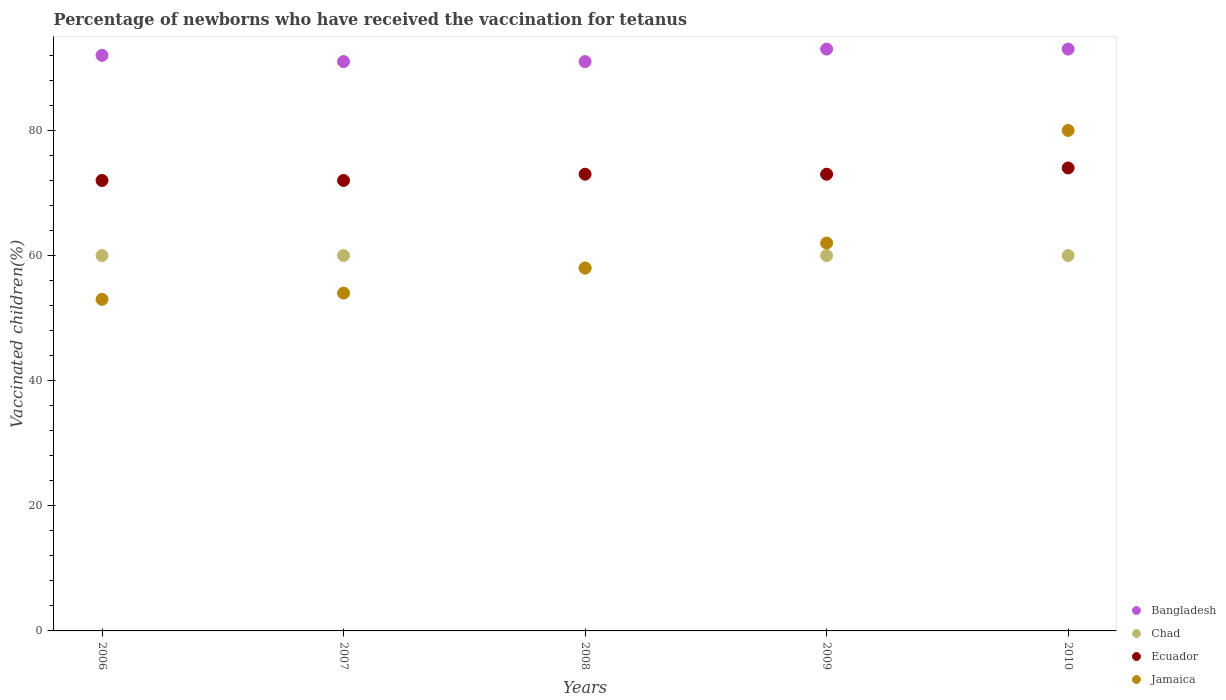Is the number of dotlines equal to the number of legend labels?
Make the answer very short. Yes. What is the percentage of vaccinated children in Bangladesh in 2010?
Give a very brief answer. 93. Across all years, what is the maximum percentage of vaccinated children in Bangladesh?
Offer a very short reply. 93. Across all years, what is the minimum percentage of vaccinated children in Chad?
Provide a short and direct response. 58. In which year was the percentage of vaccinated children in Bangladesh maximum?
Provide a short and direct response. 2009. What is the total percentage of vaccinated children in Jamaica in the graph?
Make the answer very short. 307. What is the difference between the percentage of vaccinated children in Jamaica in 2009 and the percentage of vaccinated children in Bangladesh in 2007?
Give a very brief answer. -29. What is the average percentage of vaccinated children in Jamaica per year?
Provide a succinct answer. 61.4. What is the ratio of the percentage of vaccinated children in Chad in 2007 to that in 2009?
Offer a very short reply. 1. Is the percentage of vaccinated children in Chad in 2007 less than that in 2008?
Provide a succinct answer. No. Is the difference between the percentage of vaccinated children in Chad in 2007 and 2010 greater than the difference between the percentage of vaccinated children in Ecuador in 2007 and 2010?
Provide a succinct answer. Yes. What is the difference between the highest and the lowest percentage of vaccinated children in Ecuador?
Provide a succinct answer. 2. Is the sum of the percentage of vaccinated children in Bangladesh in 2006 and 2009 greater than the maximum percentage of vaccinated children in Chad across all years?
Provide a short and direct response. Yes. Is it the case that in every year, the sum of the percentage of vaccinated children in Chad and percentage of vaccinated children in Bangladesh  is greater than the sum of percentage of vaccinated children in Ecuador and percentage of vaccinated children in Jamaica?
Offer a terse response. Yes. How many dotlines are there?
Make the answer very short. 4. How many years are there in the graph?
Offer a terse response. 5. What is the difference between two consecutive major ticks on the Y-axis?
Offer a very short reply. 20. Are the values on the major ticks of Y-axis written in scientific E-notation?
Provide a short and direct response. No. Does the graph contain any zero values?
Make the answer very short. No. How many legend labels are there?
Make the answer very short. 4. How are the legend labels stacked?
Provide a succinct answer. Vertical. What is the title of the graph?
Ensure brevity in your answer.  Percentage of newborns who have received the vaccination for tetanus. What is the label or title of the Y-axis?
Your answer should be compact. Vaccinated children(%). What is the Vaccinated children(%) of Bangladesh in 2006?
Your response must be concise. 92. What is the Vaccinated children(%) of Chad in 2006?
Offer a terse response. 60. What is the Vaccinated children(%) in Ecuador in 2006?
Your answer should be compact. 72. What is the Vaccinated children(%) of Bangladesh in 2007?
Offer a terse response. 91. What is the Vaccinated children(%) in Chad in 2007?
Your response must be concise. 60. What is the Vaccinated children(%) in Bangladesh in 2008?
Your answer should be compact. 91. What is the Vaccinated children(%) of Jamaica in 2008?
Offer a terse response. 58. What is the Vaccinated children(%) in Bangladesh in 2009?
Make the answer very short. 93. What is the Vaccinated children(%) in Ecuador in 2009?
Your answer should be compact. 73. What is the Vaccinated children(%) in Bangladesh in 2010?
Your answer should be very brief. 93. What is the Vaccinated children(%) of Jamaica in 2010?
Provide a short and direct response. 80. Across all years, what is the maximum Vaccinated children(%) of Bangladesh?
Make the answer very short. 93. Across all years, what is the maximum Vaccinated children(%) of Chad?
Your response must be concise. 60. Across all years, what is the maximum Vaccinated children(%) of Ecuador?
Your answer should be compact. 74. Across all years, what is the maximum Vaccinated children(%) of Jamaica?
Provide a succinct answer. 80. Across all years, what is the minimum Vaccinated children(%) in Bangladesh?
Make the answer very short. 91. What is the total Vaccinated children(%) of Bangladesh in the graph?
Ensure brevity in your answer.  460. What is the total Vaccinated children(%) in Chad in the graph?
Keep it short and to the point. 298. What is the total Vaccinated children(%) in Ecuador in the graph?
Your answer should be very brief. 364. What is the total Vaccinated children(%) of Jamaica in the graph?
Keep it short and to the point. 307. What is the difference between the Vaccinated children(%) of Bangladesh in 2006 and that in 2007?
Provide a short and direct response. 1. What is the difference between the Vaccinated children(%) in Jamaica in 2006 and that in 2007?
Make the answer very short. -1. What is the difference between the Vaccinated children(%) in Chad in 2006 and that in 2008?
Make the answer very short. 2. What is the difference between the Vaccinated children(%) of Bangladesh in 2006 and that in 2009?
Ensure brevity in your answer.  -1. What is the difference between the Vaccinated children(%) of Chad in 2006 and that in 2009?
Your answer should be compact. 0. What is the difference between the Vaccinated children(%) in Ecuador in 2006 and that in 2009?
Your answer should be very brief. -1. What is the difference between the Vaccinated children(%) in Jamaica in 2006 and that in 2009?
Your answer should be very brief. -9. What is the difference between the Vaccinated children(%) in Bangladesh in 2006 and that in 2010?
Offer a terse response. -1. What is the difference between the Vaccinated children(%) in Chad in 2006 and that in 2010?
Ensure brevity in your answer.  0. What is the difference between the Vaccinated children(%) in Jamaica in 2006 and that in 2010?
Provide a short and direct response. -27. What is the difference between the Vaccinated children(%) of Ecuador in 2007 and that in 2008?
Offer a terse response. -1. What is the difference between the Vaccinated children(%) in Ecuador in 2007 and that in 2009?
Ensure brevity in your answer.  -1. What is the difference between the Vaccinated children(%) in Jamaica in 2007 and that in 2009?
Offer a very short reply. -8. What is the difference between the Vaccinated children(%) of Bangladesh in 2007 and that in 2010?
Provide a short and direct response. -2. What is the difference between the Vaccinated children(%) of Chad in 2007 and that in 2010?
Give a very brief answer. 0. What is the difference between the Vaccinated children(%) in Ecuador in 2007 and that in 2010?
Your answer should be compact. -2. What is the difference between the Vaccinated children(%) of Jamaica in 2007 and that in 2010?
Provide a short and direct response. -26. What is the difference between the Vaccinated children(%) of Bangladesh in 2008 and that in 2009?
Offer a terse response. -2. What is the difference between the Vaccinated children(%) in Bangladesh in 2008 and that in 2010?
Your answer should be compact. -2. What is the difference between the Vaccinated children(%) of Jamaica in 2009 and that in 2010?
Your answer should be compact. -18. What is the difference between the Vaccinated children(%) of Bangladesh in 2006 and the Vaccinated children(%) of Jamaica in 2007?
Offer a very short reply. 38. What is the difference between the Vaccinated children(%) in Chad in 2006 and the Vaccinated children(%) in Ecuador in 2007?
Provide a succinct answer. -12. What is the difference between the Vaccinated children(%) in Chad in 2006 and the Vaccinated children(%) in Jamaica in 2007?
Keep it short and to the point. 6. What is the difference between the Vaccinated children(%) of Ecuador in 2006 and the Vaccinated children(%) of Jamaica in 2007?
Your response must be concise. 18. What is the difference between the Vaccinated children(%) of Bangladesh in 2006 and the Vaccinated children(%) of Jamaica in 2008?
Offer a terse response. 34. What is the difference between the Vaccinated children(%) in Chad in 2006 and the Vaccinated children(%) in Ecuador in 2008?
Your answer should be compact. -13. What is the difference between the Vaccinated children(%) in Chad in 2006 and the Vaccinated children(%) in Jamaica in 2008?
Provide a succinct answer. 2. What is the difference between the Vaccinated children(%) in Ecuador in 2006 and the Vaccinated children(%) in Jamaica in 2008?
Provide a succinct answer. 14. What is the difference between the Vaccinated children(%) in Bangladesh in 2006 and the Vaccinated children(%) in Ecuador in 2009?
Offer a very short reply. 19. What is the difference between the Vaccinated children(%) of Bangladesh in 2006 and the Vaccinated children(%) of Jamaica in 2009?
Your answer should be compact. 30. What is the difference between the Vaccinated children(%) of Bangladesh in 2006 and the Vaccinated children(%) of Ecuador in 2010?
Your answer should be very brief. 18. What is the difference between the Vaccinated children(%) in Bangladesh in 2006 and the Vaccinated children(%) in Jamaica in 2010?
Make the answer very short. 12. What is the difference between the Vaccinated children(%) in Chad in 2006 and the Vaccinated children(%) in Ecuador in 2010?
Offer a terse response. -14. What is the difference between the Vaccinated children(%) in Chad in 2006 and the Vaccinated children(%) in Jamaica in 2010?
Make the answer very short. -20. What is the difference between the Vaccinated children(%) of Ecuador in 2006 and the Vaccinated children(%) of Jamaica in 2010?
Provide a succinct answer. -8. What is the difference between the Vaccinated children(%) of Bangladesh in 2007 and the Vaccinated children(%) of Ecuador in 2008?
Make the answer very short. 18. What is the difference between the Vaccinated children(%) in Chad in 2007 and the Vaccinated children(%) in Ecuador in 2008?
Keep it short and to the point. -13. What is the difference between the Vaccinated children(%) of Chad in 2007 and the Vaccinated children(%) of Jamaica in 2008?
Provide a succinct answer. 2. What is the difference between the Vaccinated children(%) in Bangladesh in 2007 and the Vaccinated children(%) in Chad in 2009?
Ensure brevity in your answer.  31. What is the difference between the Vaccinated children(%) in Bangladesh in 2007 and the Vaccinated children(%) in Ecuador in 2009?
Give a very brief answer. 18. What is the difference between the Vaccinated children(%) in Chad in 2007 and the Vaccinated children(%) in Ecuador in 2009?
Provide a succinct answer. -13. What is the difference between the Vaccinated children(%) of Chad in 2007 and the Vaccinated children(%) of Jamaica in 2009?
Keep it short and to the point. -2. What is the difference between the Vaccinated children(%) in Ecuador in 2007 and the Vaccinated children(%) in Jamaica in 2009?
Keep it short and to the point. 10. What is the difference between the Vaccinated children(%) in Bangladesh in 2007 and the Vaccinated children(%) in Chad in 2010?
Your response must be concise. 31. What is the difference between the Vaccinated children(%) of Bangladesh in 2008 and the Vaccinated children(%) of Chad in 2009?
Provide a succinct answer. 31. What is the difference between the Vaccinated children(%) of Bangladesh in 2008 and the Vaccinated children(%) of Ecuador in 2009?
Your answer should be compact. 18. What is the difference between the Vaccinated children(%) in Bangladesh in 2008 and the Vaccinated children(%) in Jamaica in 2009?
Give a very brief answer. 29. What is the difference between the Vaccinated children(%) in Chad in 2008 and the Vaccinated children(%) in Jamaica in 2009?
Give a very brief answer. -4. What is the difference between the Vaccinated children(%) of Ecuador in 2008 and the Vaccinated children(%) of Jamaica in 2009?
Your answer should be very brief. 11. What is the difference between the Vaccinated children(%) in Bangladesh in 2008 and the Vaccinated children(%) in Chad in 2010?
Ensure brevity in your answer.  31. What is the difference between the Vaccinated children(%) in Bangladesh in 2008 and the Vaccinated children(%) in Ecuador in 2010?
Your answer should be very brief. 17. What is the difference between the Vaccinated children(%) in Bangladesh in 2008 and the Vaccinated children(%) in Jamaica in 2010?
Provide a short and direct response. 11. What is the difference between the Vaccinated children(%) of Chad in 2008 and the Vaccinated children(%) of Jamaica in 2010?
Provide a short and direct response. -22. What is the difference between the Vaccinated children(%) of Bangladesh in 2009 and the Vaccinated children(%) of Chad in 2010?
Your answer should be very brief. 33. What is the difference between the Vaccinated children(%) of Bangladesh in 2009 and the Vaccinated children(%) of Ecuador in 2010?
Provide a short and direct response. 19. What is the difference between the Vaccinated children(%) in Bangladesh in 2009 and the Vaccinated children(%) in Jamaica in 2010?
Your answer should be compact. 13. What is the difference between the Vaccinated children(%) of Chad in 2009 and the Vaccinated children(%) of Jamaica in 2010?
Keep it short and to the point. -20. What is the difference between the Vaccinated children(%) of Ecuador in 2009 and the Vaccinated children(%) of Jamaica in 2010?
Offer a very short reply. -7. What is the average Vaccinated children(%) in Bangladesh per year?
Keep it short and to the point. 92. What is the average Vaccinated children(%) of Chad per year?
Keep it short and to the point. 59.6. What is the average Vaccinated children(%) in Ecuador per year?
Offer a terse response. 72.8. What is the average Vaccinated children(%) in Jamaica per year?
Provide a succinct answer. 61.4. In the year 2006, what is the difference between the Vaccinated children(%) in Bangladesh and Vaccinated children(%) in Ecuador?
Provide a short and direct response. 20. In the year 2006, what is the difference between the Vaccinated children(%) in Bangladesh and Vaccinated children(%) in Jamaica?
Offer a terse response. 39. In the year 2006, what is the difference between the Vaccinated children(%) in Ecuador and Vaccinated children(%) in Jamaica?
Keep it short and to the point. 19. In the year 2007, what is the difference between the Vaccinated children(%) in Chad and Vaccinated children(%) in Ecuador?
Offer a terse response. -12. In the year 2007, what is the difference between the Vaccinated children(%) of Ecuador and Vaccinated children(%) of Jamaica?
Provide a succinct answer. 18. In the year 2008, what is the difference between the Vaccinated children(%) of Bangladesh and Vaccinated children(%) of Ecuador?
Keep it short and to the point. 18. In the year 2008, what is the difference between the Vaccinated children(%) of Bangladesh and Vaccinated children(%) of Jamaica?
Your answer should be very brief. 33. In the year 2008, what is the difference between the Vaccinated children(%) of Chad and Vaccinated children(%) of Ecuador?
Ensure brevity in your answer.  -15. In the year 2008, what is the difference between the Vaccinated children(%) of Chad and Vaccinated children(%) of Jamaica?
Keep it short and to the point. 0. In the year 2008, what is the difference between the Vaccinated children(%) in Ecuador and Vaccinated children(%) in Jamaica?
Keep it short and to the point. 15. In the year 2009, what is the difference between the Vaccinated children(%) of Bangladesh and Vaccinated children(%) of Chad?
Ensure brevity in your answer.  33. In the year 2009, what is the difference between the Vaccinated children(%) of Ecuador and Vaccinated children(%) of Jamaica?
Offer a terse response. 11. In the year 2010, what is the difference between the Vaccinated children(%) in Bangladesh and Vaccinated children(%) in Chad?
Your response must be concise. 33. In the year 2010, what is the difference between the Vaccinated children(%) of Bangladesh and Vaccinated children(%) of Ecuador?
Ensure brevity in your answer.  19. In the year 2010, what is the difference between the Vaccinated children(%) of Chad and Vaccinated children(%) of Jamaica?
Give a very brief answer. -20. In the year 2010, what is the difference between the Vaccinated children(%) in Ecuador and Vaccinated children(%) in Jamaica?
Your response must be concise. -6. What is the ratio of the Vaccinated children(%) in Ecuador in 2006 to that in 2007?
Offer a very short reply. 1. What is the ratio of the Vaccinated children(%) in Jamaica in 2006 to that in 2007?
Make the answer very short. 0.98. What is the ratio of the Vaccinated children(%) in Bangladesh in 2006 to that in 2008?
Ensure brevity in your answer.  1.01. What is the ratio of the Vaccinated children(%) of Chad in 2006 to that in 2008?
Offer a terse response. 1.03. What is the ratio of the Vaccinated children(%) in Ecuador in 2006 to that in 2008?
Your answer should be compact. 0.99. What is the ratio of the Vaccinated children(%) of Jamaica in 2006 to that in 2008?
Offer a very short reply. 0.91. What is the ratio of the Vaccinated children(%) in Ecuador in 2006 to that in 2009?
Provide a short and direct response. 0.99. What is the ratio of the Vaccinated children(%) of Jamaica in 2006 to that in 2009?
Give a very brief answer. 0.85. What is the ratio of the Vaccinated children(%) in Jamaica in 2006 to that in 2010?
Offer a terse response. 0.66. What is the ratio of the Vaccinated children(%) in Bangladesh in 2007 to that in 2008?
Ensure brevity in your answer.  1. What is the ratio of the Vaccinated children(%) in Chad in 2007 to that in 2008?
Your response must be concise. 1.03. What is the ratio of the Vaccinated children(%) in Ecuador in 2007 to that in 2008?
Offer a very short reply. 0.99. What is the ratio of the Vaccinated children(%) in Bangladesh in 2007 to that in 2009?
Provide a short and direct response. 0.98. What is the ratio of the Vaccinated children(%) of Chad in 2007 to that in 2009?
Ensure brevity in your answer.  1. What is the ratio of the Vaccinated children(%) of Ecuador in 2007 to that in 2009?
Ensure brevity in your answer.  0.99. What is the ratio of the Vaccinated children(%) of Jamaica in 2007 to that in 2009?
Your response must be concise. 0.87. What is the ratio of the Vaccinated children(%) of Bangladesh in 2007 to that in 2010?
Your response must be concise. 0.98. What is the ratio of the Vaccinated children(%) of Ecuador in 2007 to that in 2010?
Keep it short and to the point. 0.97. What is the ratio of the Vaccinated children(%) of Jamaica in 2007 to that in 2010?
Make the answer very short. 0.68. What is the ratio of the Vaccinated children(%) of Bangladesh in 2008 to that in 2009?
Make the answer very short. 0.98. What is the ratio of the Vaccinated children(%) in Chad in 2008 to that in 2009?
Ensure brevity in your answer.  0.97. What is the ratio of the Vaccinated children(%) of Jamaica in 2008 to that in 2009?
Offer a very short reply. 0.94. What is the ratio of the Vaccinated children(%) in Bangladesh in 2008 to that in 2010?
Your answer should be very brief. 0.98. What is the ratio of the Vaccinated children(%) of Chad in 2008 to that in 2010?
Offer a terse response. 0.97. What is the ratio of the Vaccinated children(%) of Ecuador in 2008 to that in 2010?
Offer a very short reply. 0.99. What is the ratio of the Vaccinated children(%) in Jamaica in 2008 to that in 2010?
Keep it short and to the point. 0.72. What is the ratio of the Vaccinated children(%) in Bangladesh in 2009 to that in 2010?
Keep it short and to the point. 1. What is the ratio of the Vaccinated children(%) of Chad in 2009 to that in 2010?
Your response must be concise. 1. What is the ratio of the Vaccinated children(%) of Ecuador in 2009 to that in 2010?
Give a very brief answer. 0.99. What is the ratio of the Vaccinated children(%) in Jamaica in 2009 to that in 2010?
Your answer should be very brief. 0.78. What is the difference between the highest and the second highest Vaccinated children(%) of Bangladesh?
Your answer should be compact. 0. What is the difference between the highest and the lowest Vaccinated children(%) of Bangladesh?
Keep it short and to the point. 2. What is the difference between the highest and the lowest Vaccinated children(%) of Chad?
Offer a very short reply. 2. What is the difference between the highest and the lowest Vaccinated children(%) of Jamaica?
Your response must be concise. 27. 